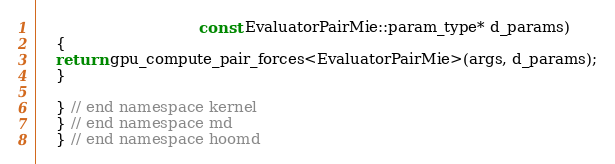Convert code to text. <code><loc_0><loc_0><loc_500><loc_500><_Cuda_>                                  const EvaluatorPairMie::param_type* d_params)
    {
    return gpu_compute_pair_forces<EvaluatorPairMie>(args, d_params);
    }

    } // end namespace kernel
    } // end namespace md
    } // end namespace hoomd
</code> 